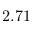<formula> <loc_0><loc_0><loc_500><loc_500>2 . 7 1</formula> 